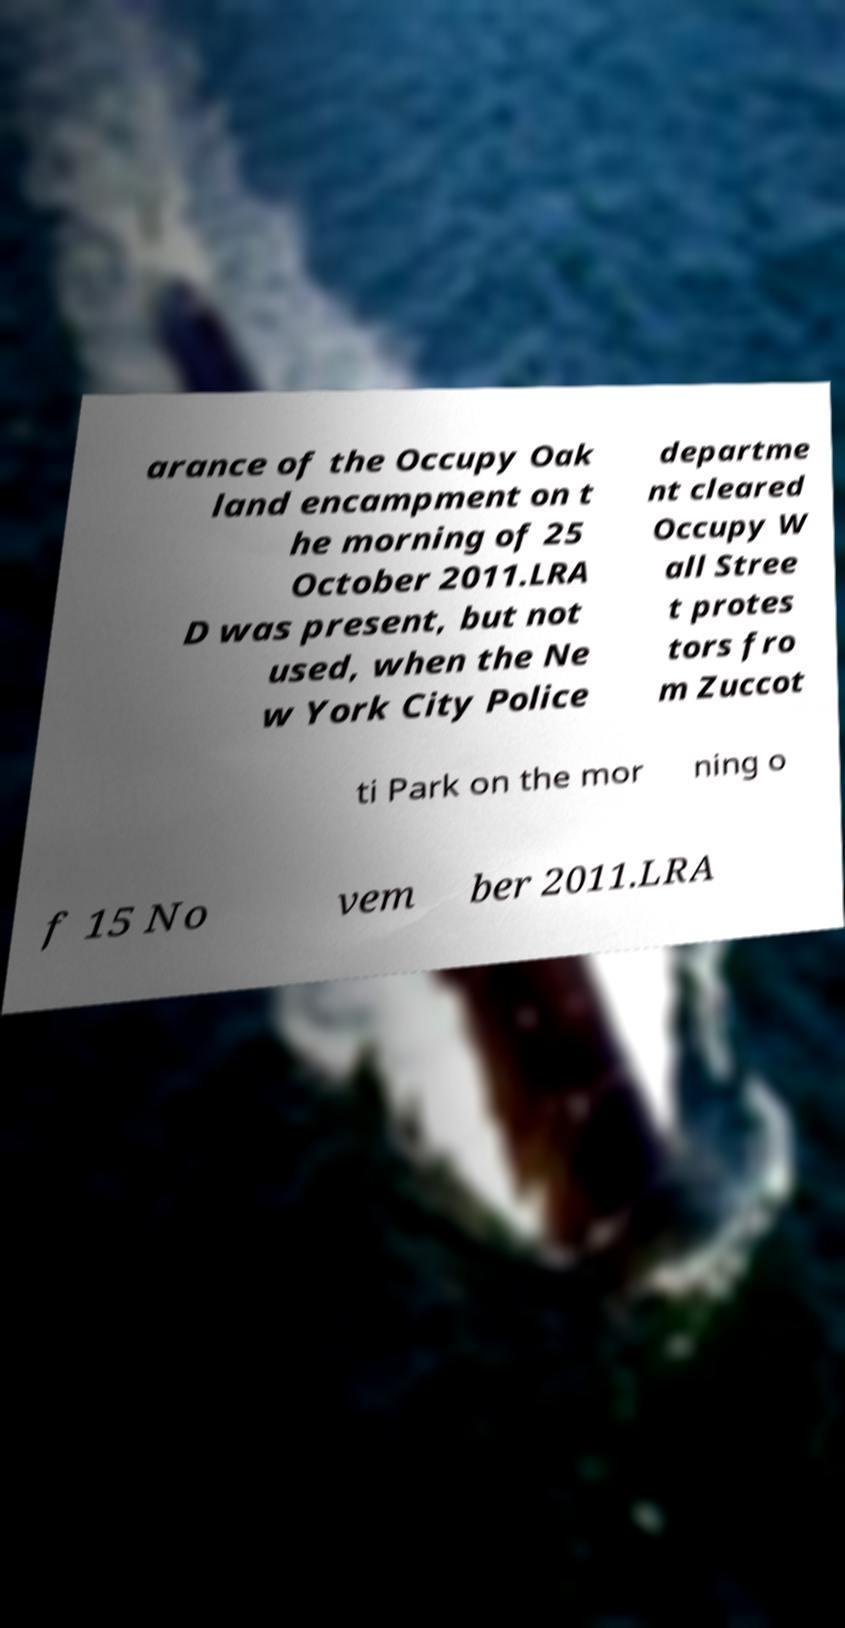Can you read and provide the text displayed in the image?This photo seems to have some interesting text. Can you extract and type it out for me? arance of the Occupy Oak land encampment on t he morning of 25 October 2011.LRA D was present, but not used, when the Ne w York City Police departme nt cleared Occupy W all Stree t protes tors fro m Zuccot ti Park on the mor ning o f 15 No vem ber 2011.LRA 